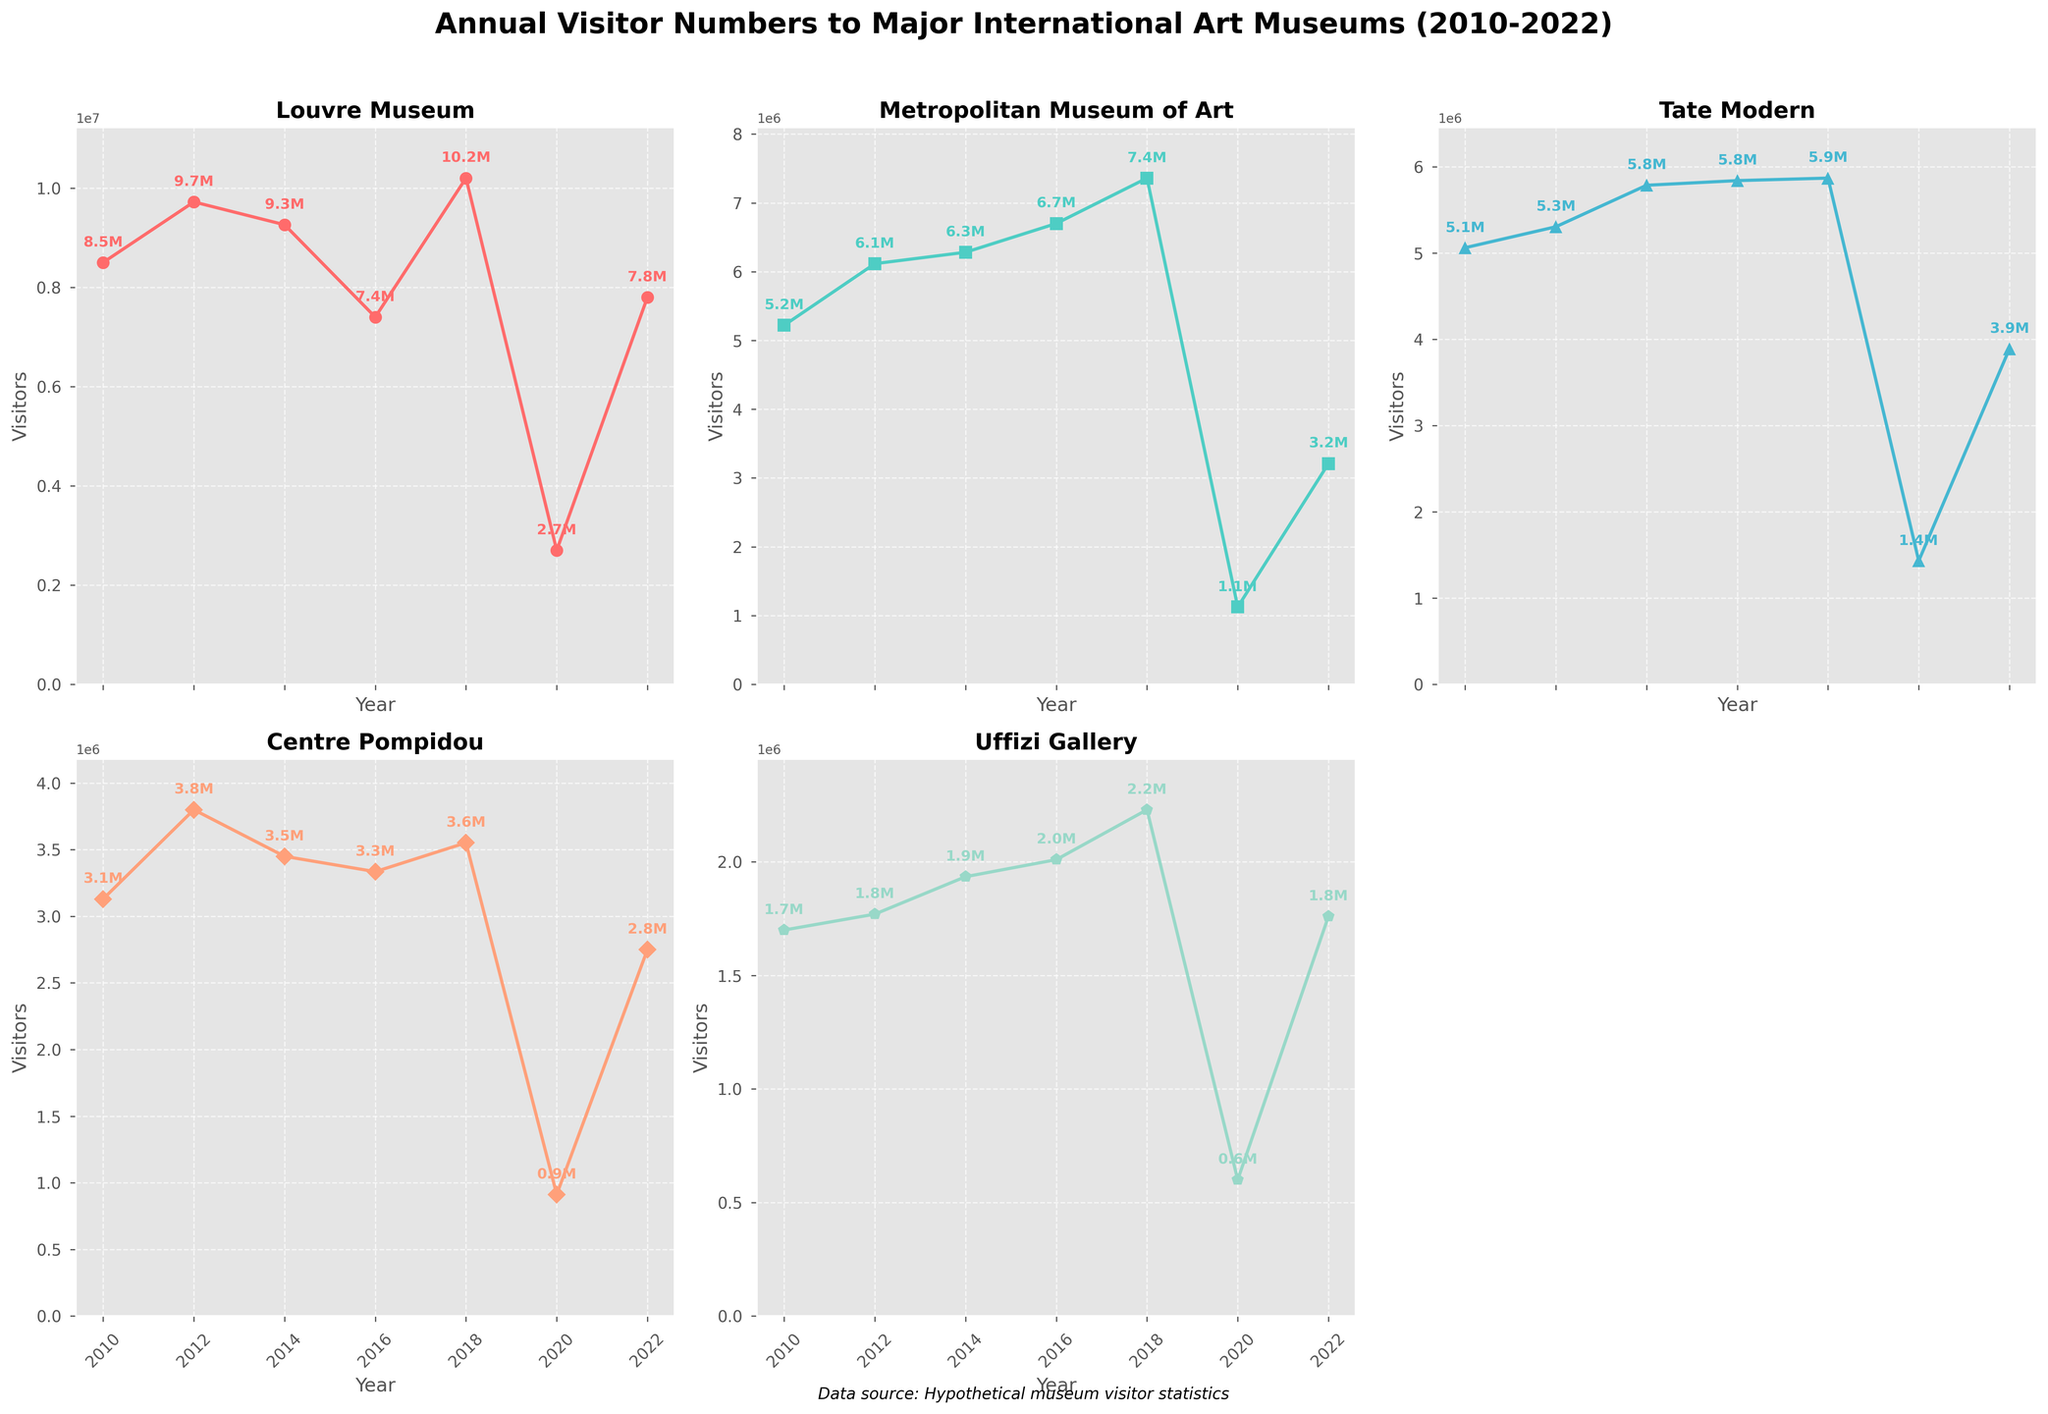What's the title of the figure? The title is displayed at the top of the figure. It reads "Annual Visitor Numbers to Major International Art Museums (2010-2022)".
Answer: Annual Visitor Numbers to Major International Art Museums (2010-2022) Which museum had the highest number of visitors in 2018? Looking at the plot for each museum for the year 2018, the Louvre Museum had the highest number at 10.2 million visitors.
Answer: Louvre Museum In which year did the Tate Modern experience its lowest number of visitors? By observing the line chart for the Tate Modern, the lowest point is in 2020, which corresponds to about 1.4 million visitors.
Answer: 2020 Calculate the average number of visitors to the Centre Pompidou from 2010 to 2022. Add the visitor numbers for each of the given years for Centre Pompidou (3.13M + 3.8M + 3.45M + 3.335M + 3.552M + 0.912M + 2.75M) and then divide by the number of years (7). (3.13 + 3.8 + 3.45 + 3.335 + 3.552 + 0.912 + 2.75) / 7 = 21.929 / 7 ≈ 3.13M
Answer: Approximately 3.13M Compare the visitors between 2010 and 2022 for the Uffizi Gallery. Which year had more visitors? By comparing the visitor numbers for the Uffizi Gallery in 2010 and 2022, the values are 1.7 million and 1.76 million, respectively.
Answer: 2022 Which museum experienced the biggest drop in visitor numbers from 2018 to 2020? Observing the plots, the Louvre Museum went from 10.2 million in 2018 to 2.7 million in 2020, a drop of 7.5 million visitors, which is the largest decline among the museums.
Answer: Louvre Museum Which museums' visitor numbers never dropped below 1 million between 2010 to 2022? By checking the plots for each museum, the Louvre Museum, the Metropolitan Museum of Art, and the Tate Modern all had years where their visitor numbers dropped significantly below 1 million, except for the Louvre Museum, which always stayed above 1 million visitors.
Answer: Louvre Museum What trend can be observed for visitor numbers across all museums in 2020? The figure shows a significant decline in visitor numbers for all museums in 2020. This can be observed by the notably low points in each of the line charts for that year.
Answer: Significant decline How did the visitor numbers for the Metropolitan Museum of Art change from 2010 to 2022? Observing the plot for the Metropolitan Museum of Art, it started with 5.22 million in 2010 and ended with 3.21 million in 2022, showing fluctuations with a peak in 2018 and then a significant drop in 2020 and a partial recovery by 2022.
Answer: Decrease with fluctuations Which years are labeled with visitor numbers in the figure for the Uffizi Gallery? By looking at the Uffizi Gallery subplot, visitor numbers are labeled for each data point in the years provided (2010, 2012, 2014, 2016, 2018, 2020, 2022).
Answer: 2010, 2012, 2014, 2016, 2018, 2020, 2022 